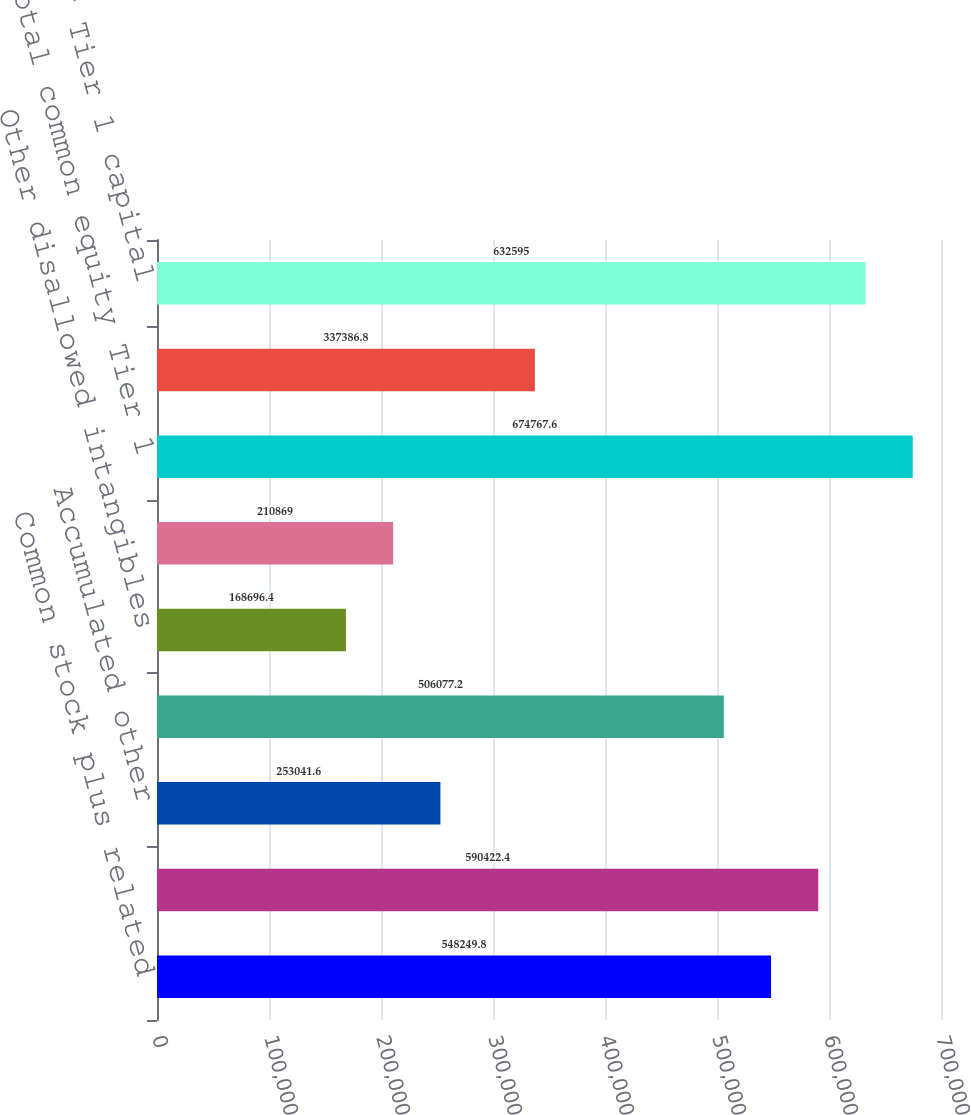Convert chart to OTSL. <chart><loc_0><loc_0><loc_500><loc_500><bar_chart><fcel>Common stock plus related<fcel>Retained earnings<fcel>Accumulated other<fcel>Goodwill net of associated<fcel>Other disallowed intangibles<fcel>Other adjustments/(deductions)<fcel>Total common equity Tier 1<fcel>Total threshold deductions<fcel>Common equity Tier 1 capital<nl><fcel>548250<fcel>590422<fcel>253042<fcel>506077<fcel>168696<fcel>210869<fcel>674768<fcel>337387<fcel>632595<nl></chart> 